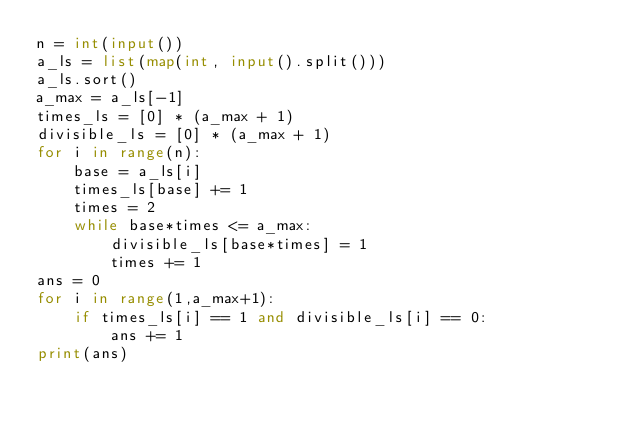Convert code to text. <code><loc_0><loc_0><loc_500><loc_500><_Python_>n = int(input())
a_ls = list(map(int, input().split()))
a_ls.sort()
a_max = a_ls[-1]
times_ls = [0] * (a_max + 1)
divisible_ls = [0] * (a_max + 1)
for i in range(n):
    base = a_ls[i]
    times_ls[base] += 1
    times = 2
    while base*times <= a_max:
        divisible_ls[base*times] = 1
        times += 1
ans = 0
for i in range(1,a_max+1):
    if times_ls[i] == 1 and divisible_ls[i] == 0:
        ans += 1
print(ans)

    </code> 